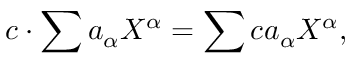Convert formula to latex. <formula><loc_0><loc_0><loc_500><loc_500>c \cdot \sum a _ { \alpha } X ^ { \alpha } = \sum c a _ { \alpha } X ^ { \alpha } ,</formula> 